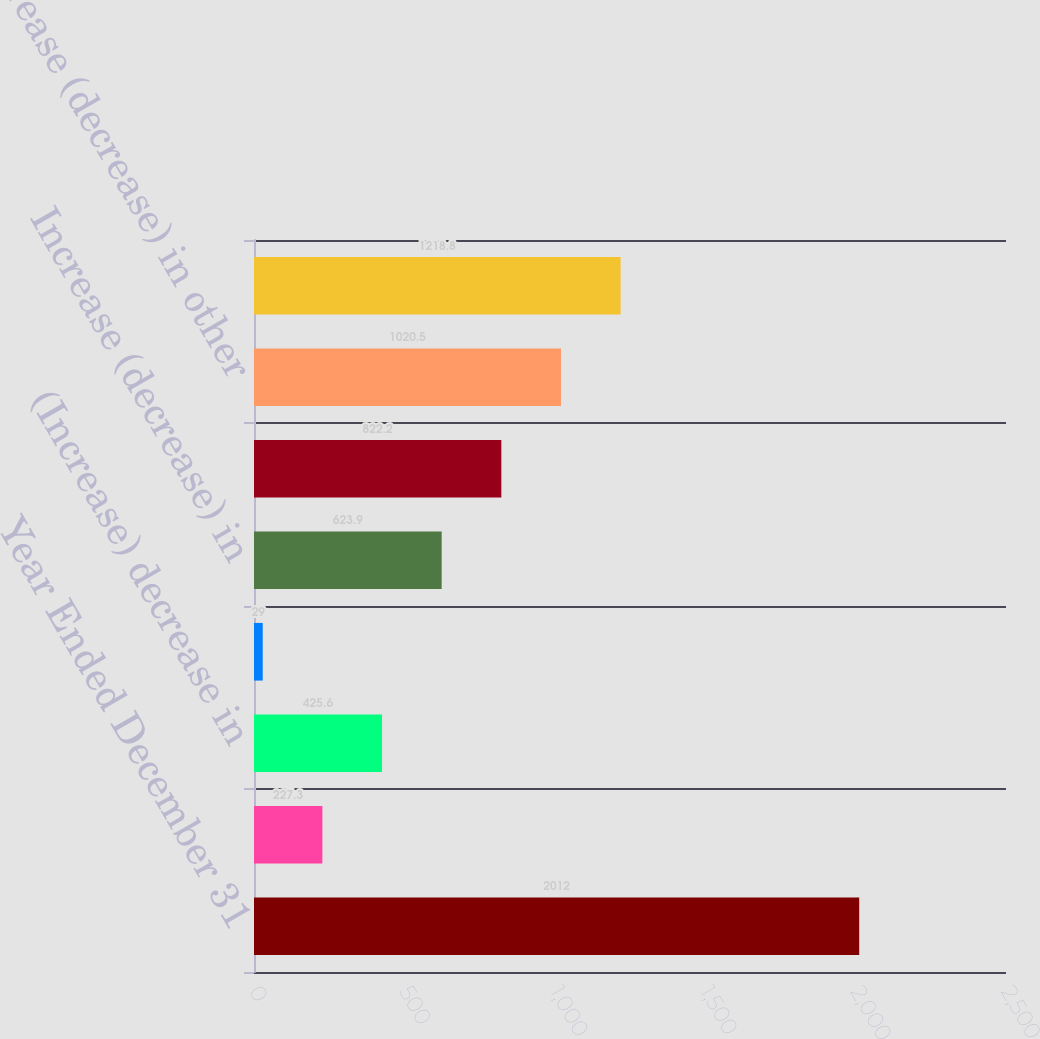Convert chart to OTSL. <chart><loc_0><loc_0><loc_500><loc_500><bar_chart><fcel>Year Ended December 31<fcel>(Increase) decrease in trade<fcel>(Increase) decrease in<fcel>(Increase) decrease in prepaid<fcel>Increase (decrease) in<fcel>Increase (decrease) in accrued<fcel>Increase (decrease) in other<fcel>Net change in operating assets<nl><fcel>2012<fcel>227.3<fcel>425.6<fcel>29<fcel>623.9<fcel>822.2<fcel>1020.5<fcel>1218.8<nl></chart> 